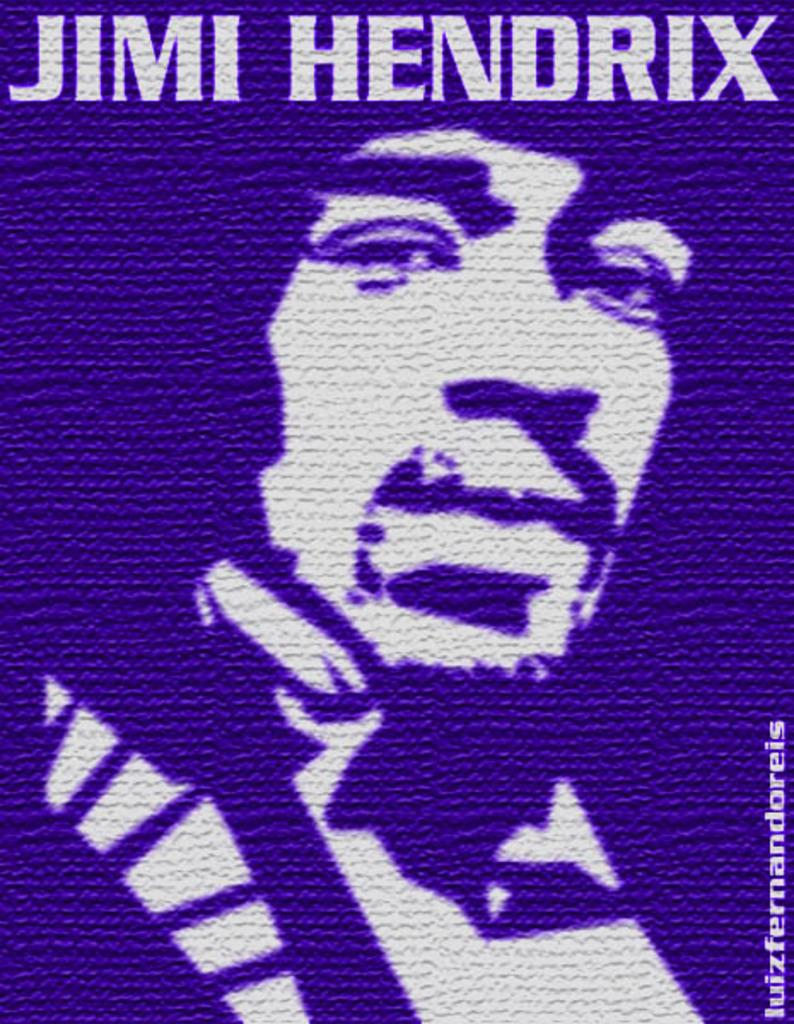Who is present in the image? There is a man in the image. What can be seen at the top of the image? There is text on the top of the image. Where is additional text located in the image? There is text at the right bottom of the image. What type of clouds can be seen in the image? There are no clouds visible in the image; it only features a man and text. 